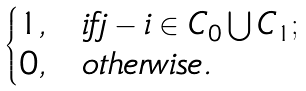Convert formula to latex. <formula><loc_0><loc_0><loc_500><loc_500>\begin{cases} 1 , & i f j - i \in C _ { 0 } \bigcup C _ { 1 } ; \\ 0 , & o t h e r w i s e . \end{cases}</formula> 